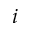Convert formula to latex. <formula><loc_0><loc_0><loc_500><loc_500>i</formula> 